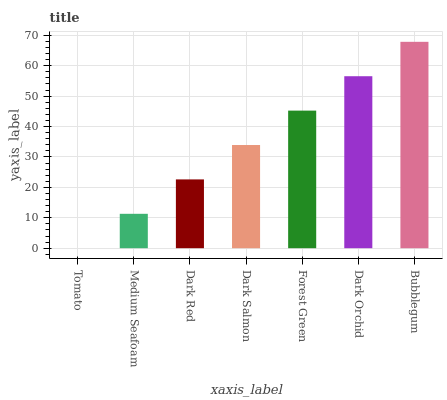Is Tomato the minimum?
Answer yes or no. Yes. Is Bubblegum the maximum?
Answer yes or no. Yes. Is Medium Seafoam the minimum?
Answer yes or no. No. Is Medium Seafoam the maximum?
Answer yes or no. No. Is Medium Seafoam greater than Tomato?
Answer yes or no. Yes. Is Tomato less than Medium Seafoam?
Answer yes or no. Yes. Is Tomato greater than Medium Seafoam?
Answer yes or no. No. Is Medium Seafoam less than Tomato?
Answer yes or no. No. Is Dark Salmon the high median?
Answer yes or no. Yes. Is Dark Salmon the low median?
Answer yes or no. Yes. Is Tomato the high median?
Answer yes or no. No. Is Tomato the low median?
Answer yes or no. No. 